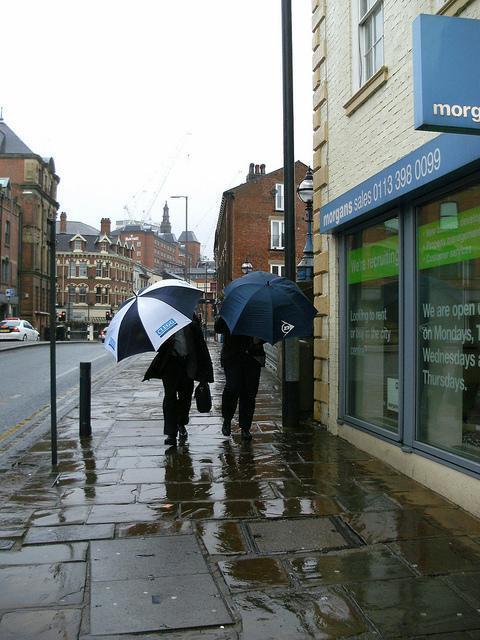How many umbrellas are there?
Give a very brief answer. 2. How many people are in the picture?
Give a very brief answer. 2. How many yellow birds are in this picture?
Give a very brief answer. 0. 